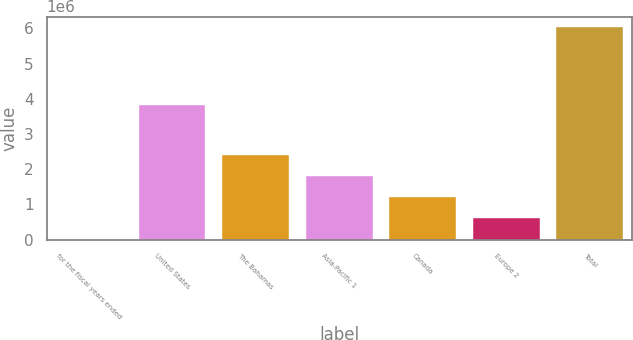Convert chart. <chart><loc_0><loc_0><loc_500><loc_500><bar_chart><fcel>for the fiscal years ended<fcel>United States<fcel>The Bahamas<fcel>Asia-Pacific 1<fcel>Canada<fcel>Europe 2<fcel>Total<nl><fcel>2008<fcel>3.82874e+06<fcel>2.41416e+06<fcel>1.81112e+06<fcel>1.20808e+06<fcel>605046<fcel>6.03239e+06<nl></chart> 